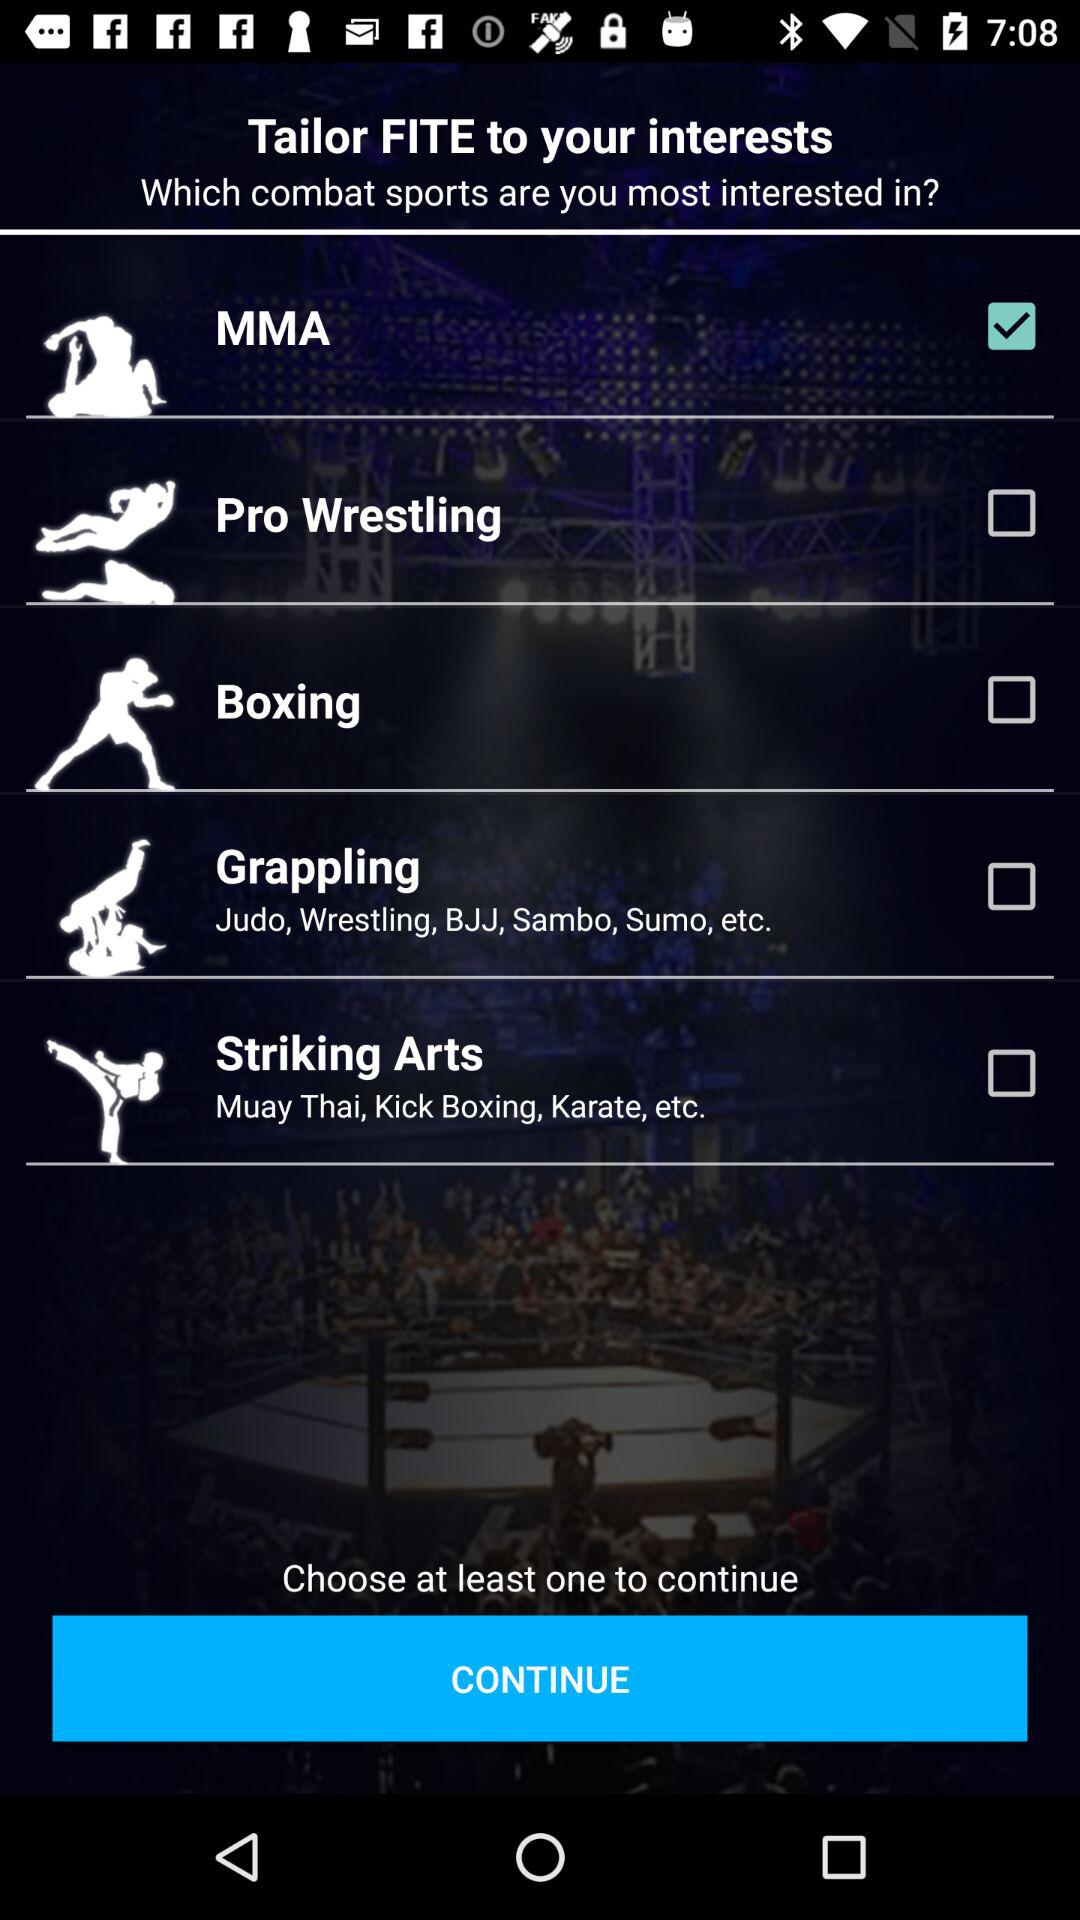What is the status of "MMA"? The status of "MMA" is "on". 